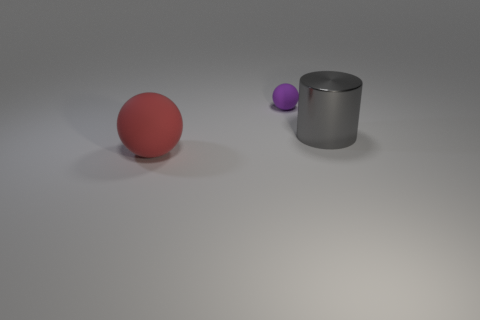Does the tiny sphere have the same color as the metallic object?
Your response must be concise. No. How many other objects are the same shape as the large gray shiny thing?
Offer a terse response. 0. What number of purple objects are large spheres or balls?
Ensure brevity in your answer.  1. The large thing that is made of the same material as the small purple sphere is what color?
Give a very brief answer. Red. Does the large object that is in front of the big gray metallic thing have the same material as the large thing that is to the right of the tiny ball?
Your response must be concise. No. What material is the ball right of the large red rubber sphere?
Provide a succinct answer. Rubber. Is the shape of the thing that is in front of the big metal cylinder the same as the large object that is to the right of the red rubber sphere?
Offer a terse response. No. Are any spheres visible?
Your answer should be compact. Yes. There is another object that is the same shape as the tiny purple matte object; what material is it?
Make the answer very short. Rubber. Are there any small purple rubber things in front of the big gray object?
Offer a terse response. No. 